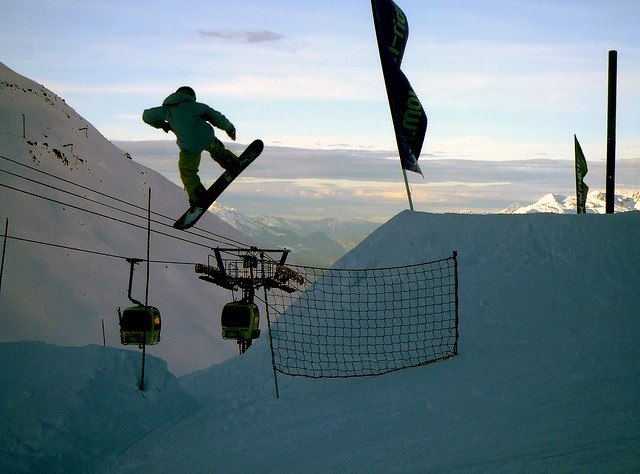Describe the objects in this image and their specific colors. I can see people in darkgray, black, darkgreen, and white tones and snowboard in darkgray, black, teal, darkgreen, and gray tones in this image. 